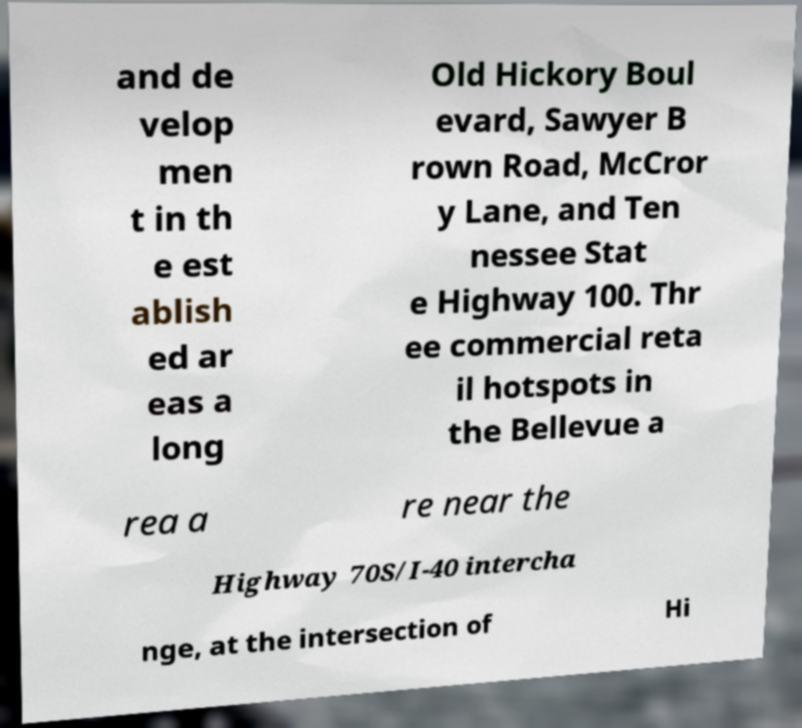I need the written content from this picture converted into text. Can you do that? and de velop men t in th e est ablish ed ar eas a long Old Hickory Boul evard, Sawyer B rown Road, McCror y Lane, and Ten nessee Stat e Highway 100. Thr ee commercial reta il hotspots in the Bellevue a rea a re near the Highway 70S/I-40 intercha nge, at the intersection of Hi 